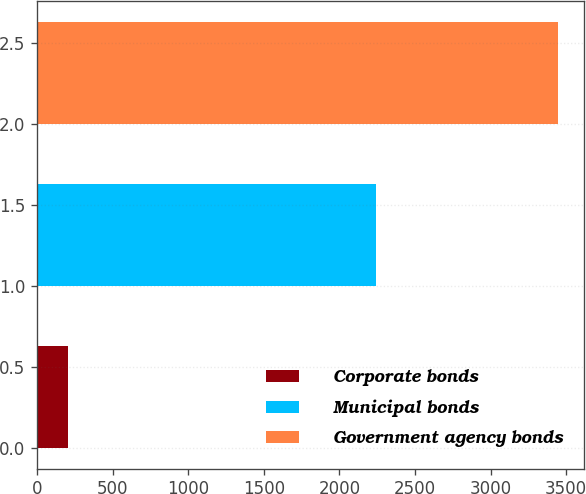<chart> <loc_0><loc_0><loc_500><loc_500><bar_chart><fcel>Corporate bonds<fcel>Municipal bonds<fcel>Government agency bonds<nl><fcel>202<fcel>2241<fcel>3445<nl></chart> 